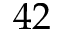Convert formula to latex. <formula><loc_0><loc_0><loc_500><loc_500>4 2</formula> 